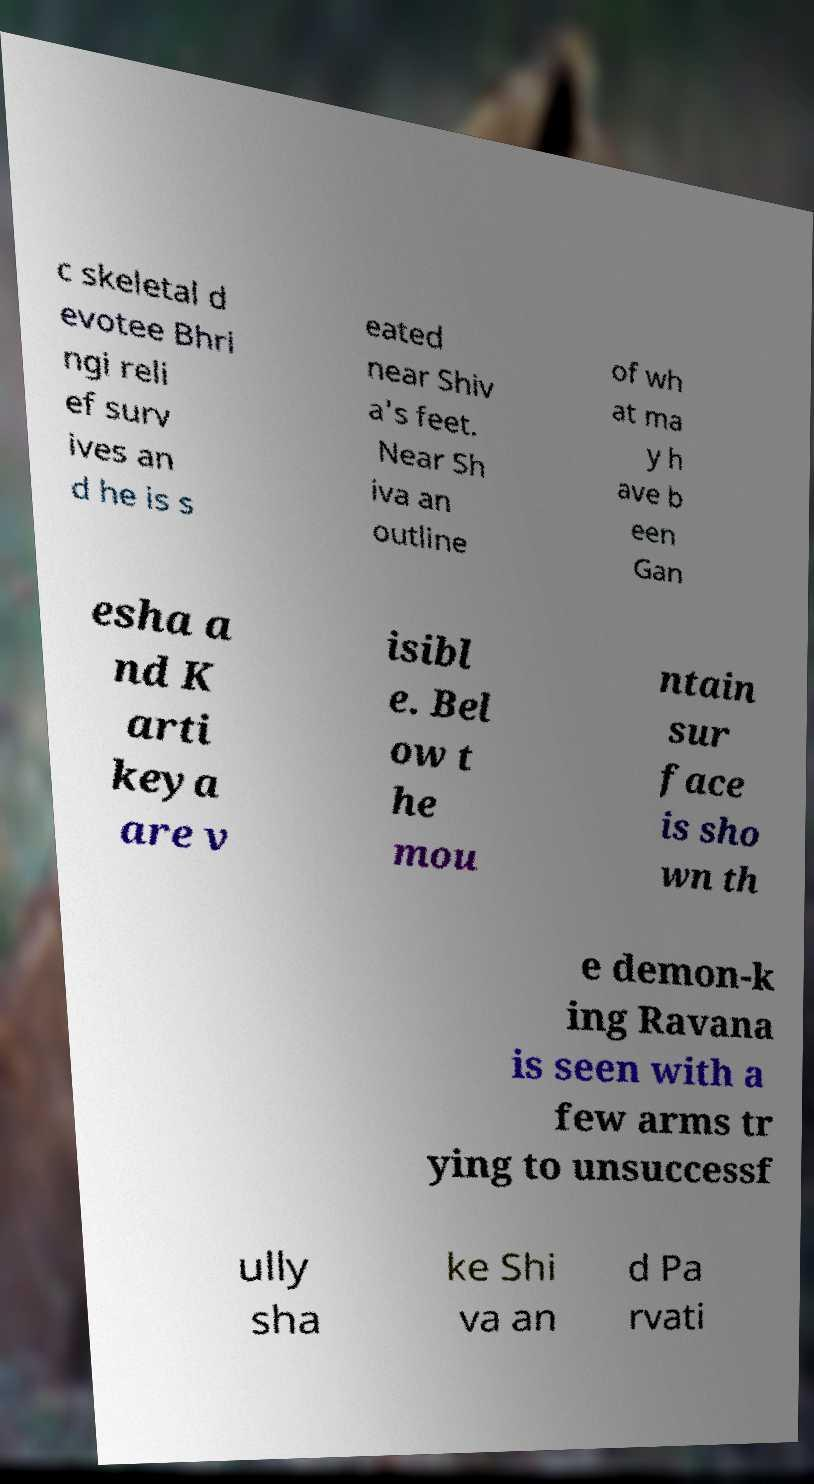I need the written content from this picture converted into text. Can you do that? c skeletal d evotee Bhri ngi reli ef surv ives an d he is s eated near Shiv a's feet. Near Sh iva an outline of wh at ma y h ave b een Gan esha a nd K arti keya are v isibl e. Bel ow t he mou ntain sur face is sho wn th e demon-k ing Ravana is seen with a few arms tr ying to unsuccessf ully sha ke Shi va an d Pa rvati 